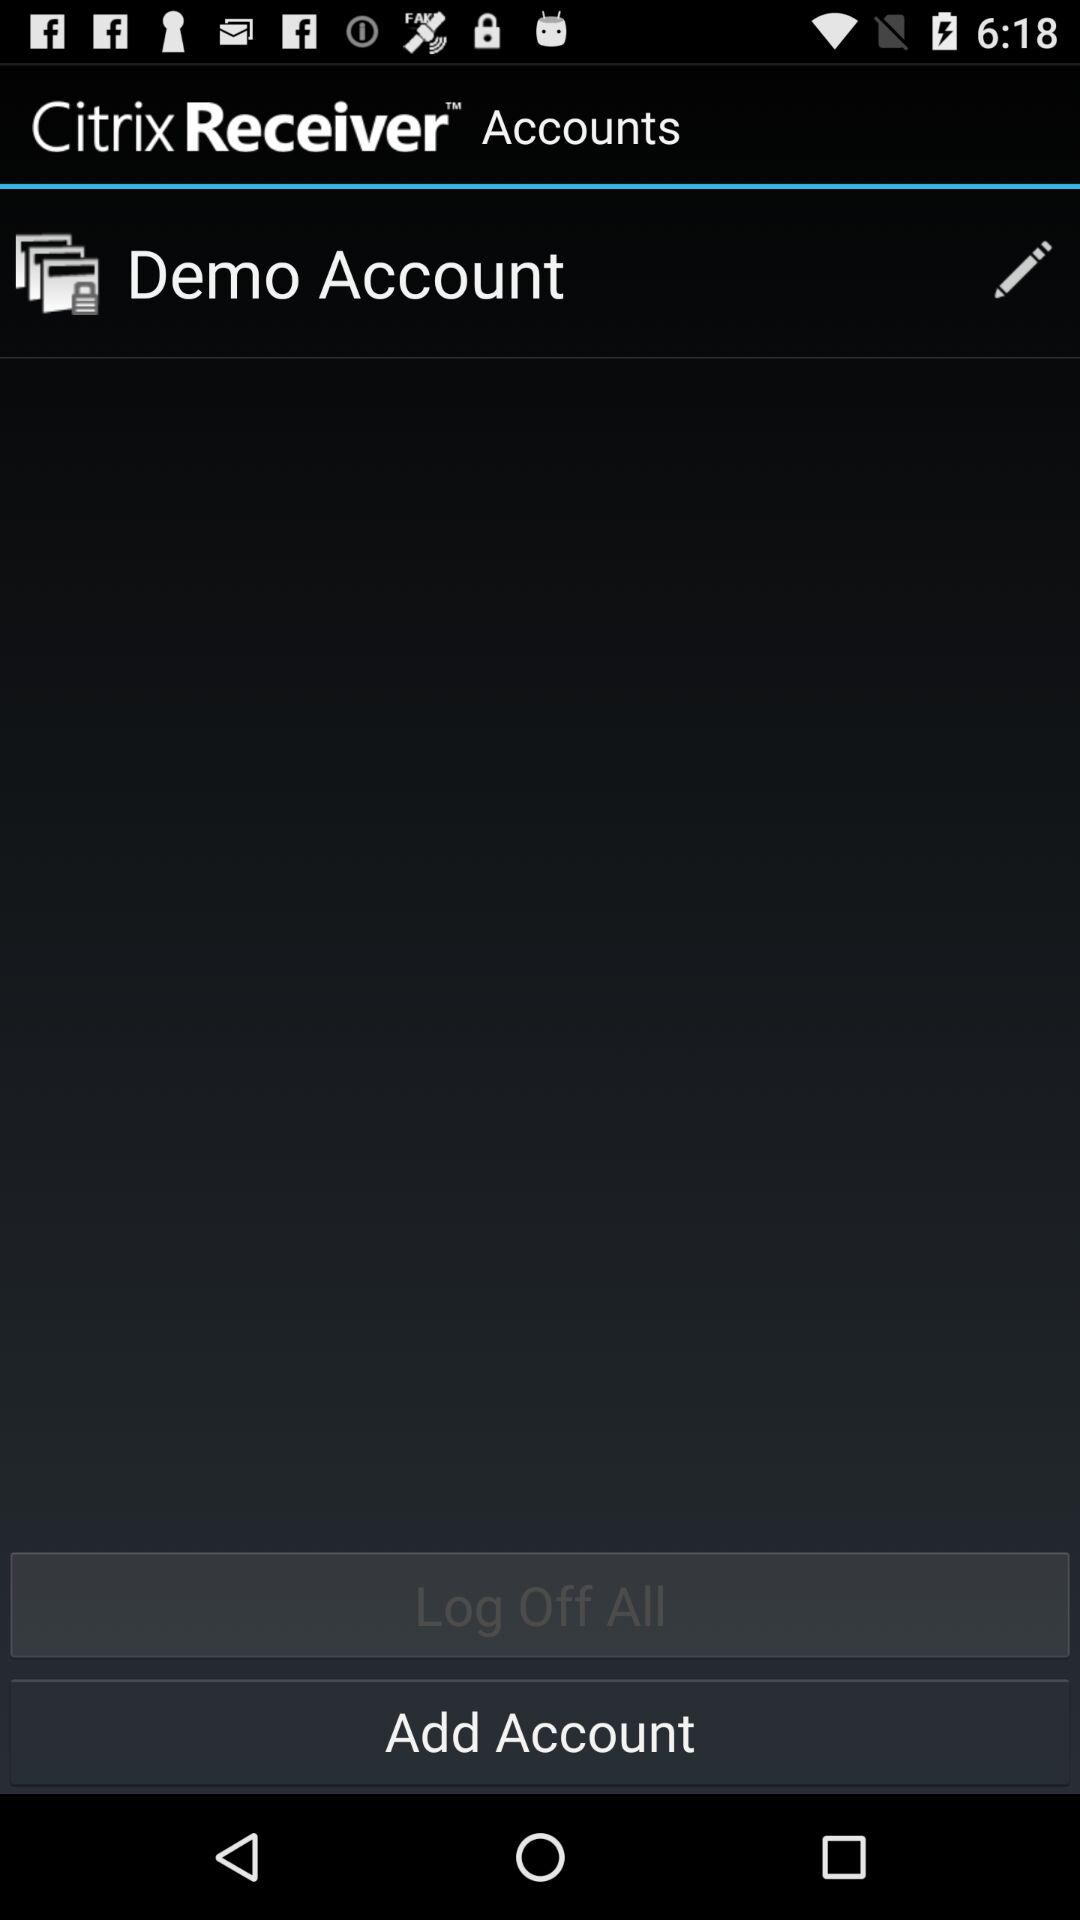What's the application name? The application name is "Citrix Receiver". 